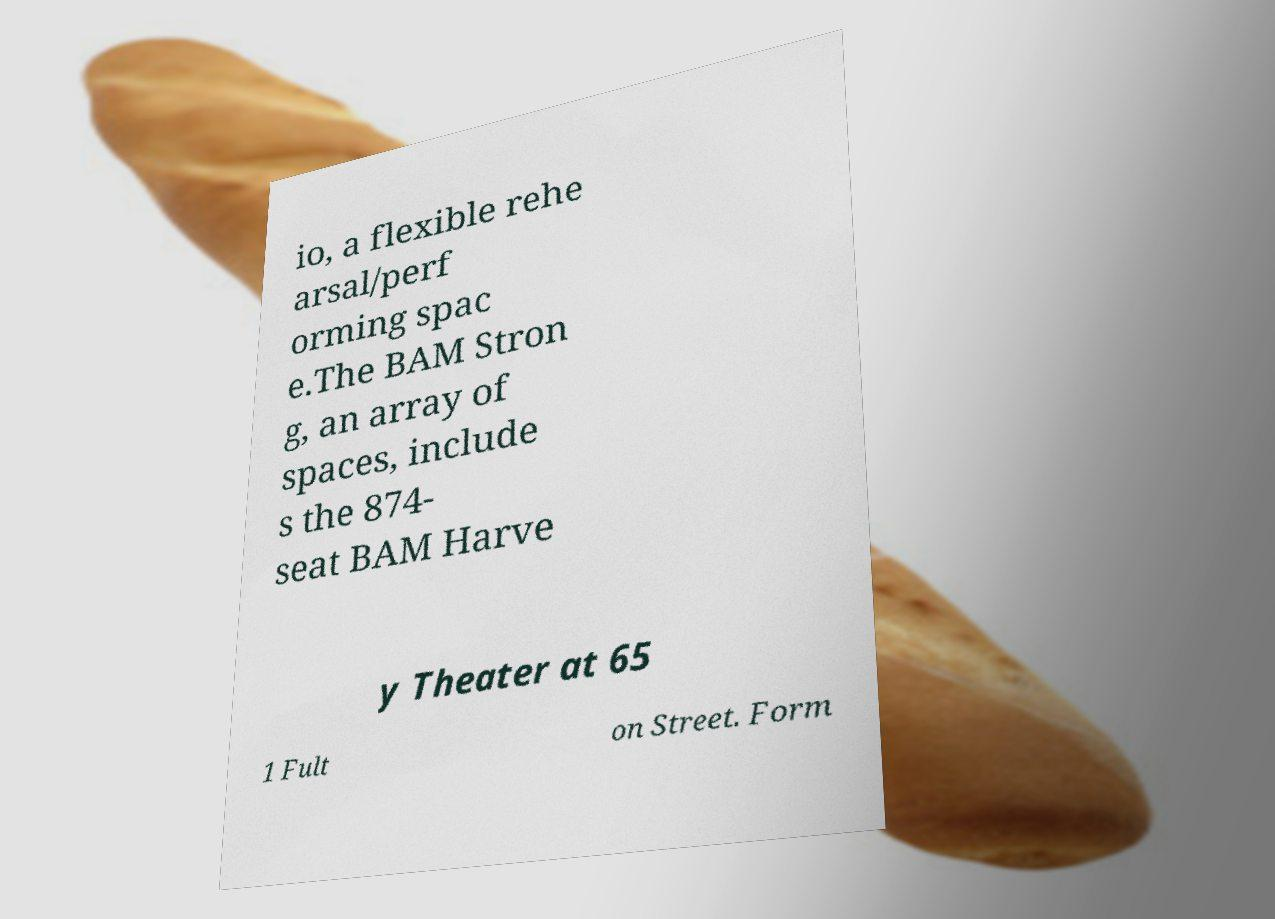For documentation purposes, I need the text within this image transcribed. Could you provide that? io, a flexible rehe arsal/perf orming spac e.The BAM Stron g, an array of spaces, include s the 874- seat BAM Harve y Theater at 65 1 Fult on Street. Form 